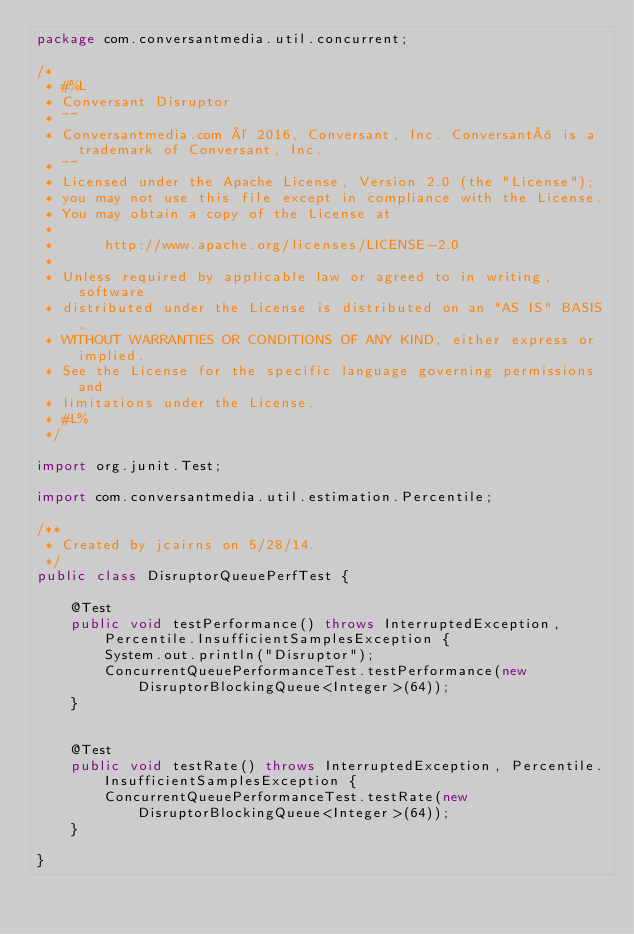<code> <loc_0><loc_0><loc_500><loc_500><_Java_>package com.conversantmedia.util.concurrent;

/*
 * #%L
 * Conversant Disruptor
 * ~~
 * Conversantmedia.com © 2016, Conversant, Inc. Conversant® is a trademark of Conversant, Inc.
 * ~~
 * Licensed under the Apache License, Version 2.0 (the "License");
 * you may not use this file except in compliance with the License.
 * You may obtain a copy of the License at
 *
 *      http://www.apache.org/licenses/LICENSE-2.0
 *
 * Unless required by applicable law or agreed to in writing, software
 * distributed under the License is distributed on an "AS IS" BASIS,
 * WITHOUT WARRANTIES OR CONDITIONS OF ANY KIND, either express or implied.
 * See the License for the specific language governing permissions and
 * limitations under the License.
 * #L%
 */

import org.junit.Test;

import com.conversantmedia.util.estimation.Percentile;

/**
 * Created by jcairns on 5/28/14.
 */
public class DisruptorQueuePerfTest {

    @Test
    public void testPerformance() throws InterruptedException, Percentile.InsufficientSamplesException {
        System.out.println("Disruptor");
        ConcurrentQueuePerformanceTest.testPerformance(new DisruptorBlockingQueue<Integer>(64));
    }


    @Test
    public void testRate() throws InterruptedException, Percentile.InsufficientSamplesException {
        ConcurrentQueuePerformanceTest.testRate(new DisruptorBlockingQueue<Integer>(64));
    }

}
</code> 